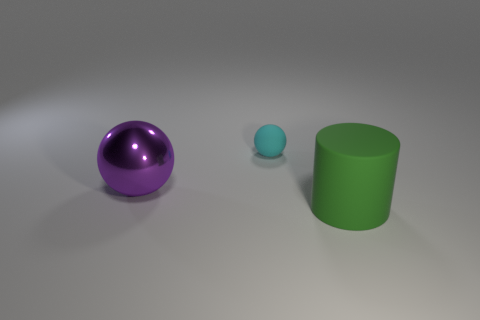What material is the big object behind the object that is right of the thing behind the big purple ball? The large object positioned behind the small blue sphere, which is to the right of the big purple ball, appears to be a green cylinder made of a matte material, likely plastic, given its visual texture and light reflection characteristics. 